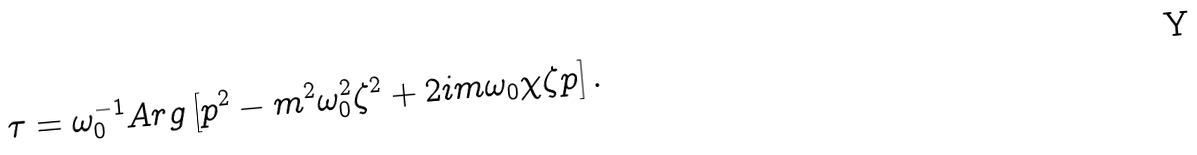<formula> <loc_0><loc_0><loc_500><loc_500>\tau = \omega _ { 0 } ^ { - 1 } A r g \left [ p ^ { 2 } - m ^ { 2 } \omega _ { 0 } ^ { 2 } \zeta ^ { 2 } + 2 i m \omega _ { 0 } \chi \zeta p \right ] .</formula> 